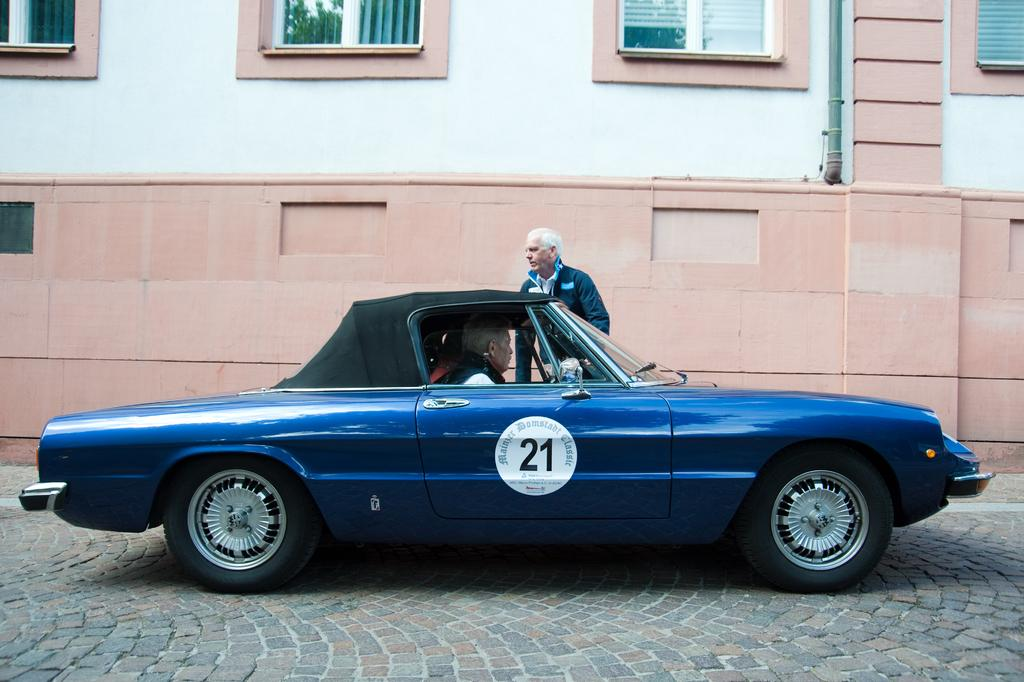What is the main subject in the center of the image? There is a car in the center of the image. Can you describe the people in the image? There are people in the image, but their specific actions or positions are not mentioned in the facts. What can be seen in the background of the image? There are windows to a building in the background. What type of surface is at the bottom of the image? There is a road at the bottom of the image. What type of ear is visible on the car in the image? There is no ear present on the car in the image; it is a vehicle, not a living being. 